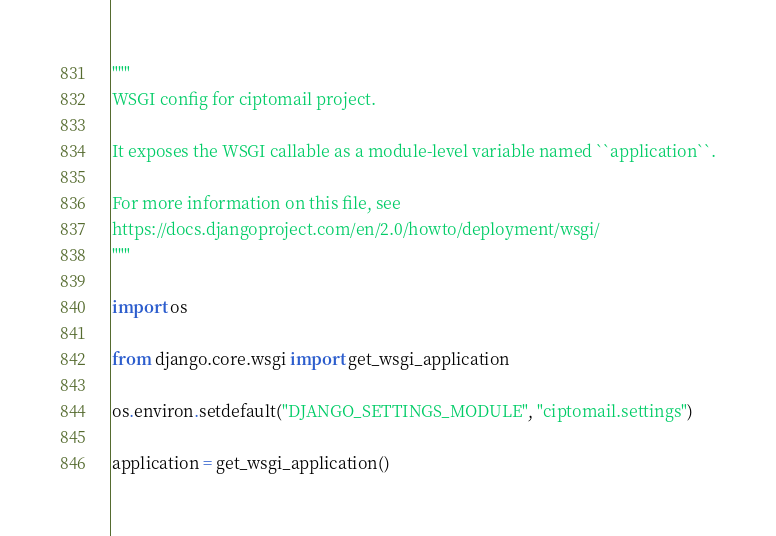<code> <loc_0><loc_0><loc_500><loc_500><_Python_>"""
WSGI config for ciptomail project.

It exposes the WSGI callable as a module-level variable named ``application``.

For more information on this file, see
https://docs.djangoproject.com/en/2.0/howto/deployment/wsgi/
"""

import os

from django.core.wsgi import get_wsgi_application

os.environ.setdefault("DJANGO_SETTINGS_MODULE", "ciptomail.settings")

application = get_wsgi_application()
</code> 